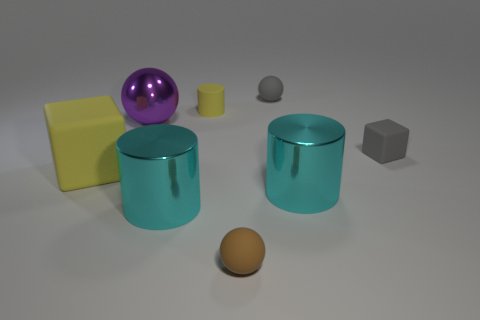How many brown spheres are the same size as the purple shiny sphere?
Offer a terse response. 0. There is a cylinder that is right of the tiny brown matte ball; does it have the same size as the gray thing behind the yellow matte cylinder?
Keep it short and to the point. No. Are there more yellow objects in front of the big metallic sphere than small brown matte spheres behind the small gray ball?
Your answer should be very brief. Yes. How many tiny gray things have the same shape as the tiny yellow object?
Provide a succinct answer. 0. What is the material of the purple sphere that is the same size as the yellow matte cube?
Offer a very short reply. Metal. Is there a large yellow object made of the same material as the yellow cylinder?
Provide a short and direct response. Yes. Is the number of large purple metallic objects to the left of the tiny block less than the number of big cyan cylinders?
Keep it short and to the point. Yes. There is a big cyan thing that is on the right side of the sphere that is in front of the gray cube; what is its material?
Give a very brief answer. Metal. There is a rubber thing that is to the left of the tiny brown rubber object and right of the yellow cube; what shape is it?
Offer a very short reply. Cylinder. How many other objects are the same color as the tiny matte cylinder?
Offer a terse response. 1. 